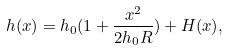<formula> <loc_0><loc_0><loc_500><loc_500>h ( x ) = h _ { 0 } ( 1 + \frac { x ^ { 2 } } { 2 h _ { 0 } R } ) + H ( x ) ,</formula> 